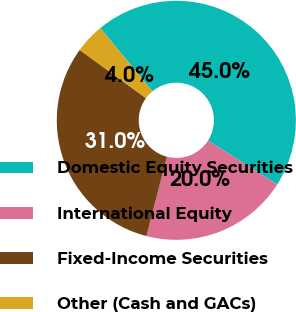Convert chart to OTSL. <chart><loc_0><loc_0><loc_500><loc_500><pie_chart><fcel>Domestic Equity Securities<fcel>International Equity<fcel>Fixed-Income Securities<fcel>Other (Cash and GACs)<nl><fcel>45.0%<fcel>20.0%<fcel>31.0%<fcel>4.0%<nl></chart> 